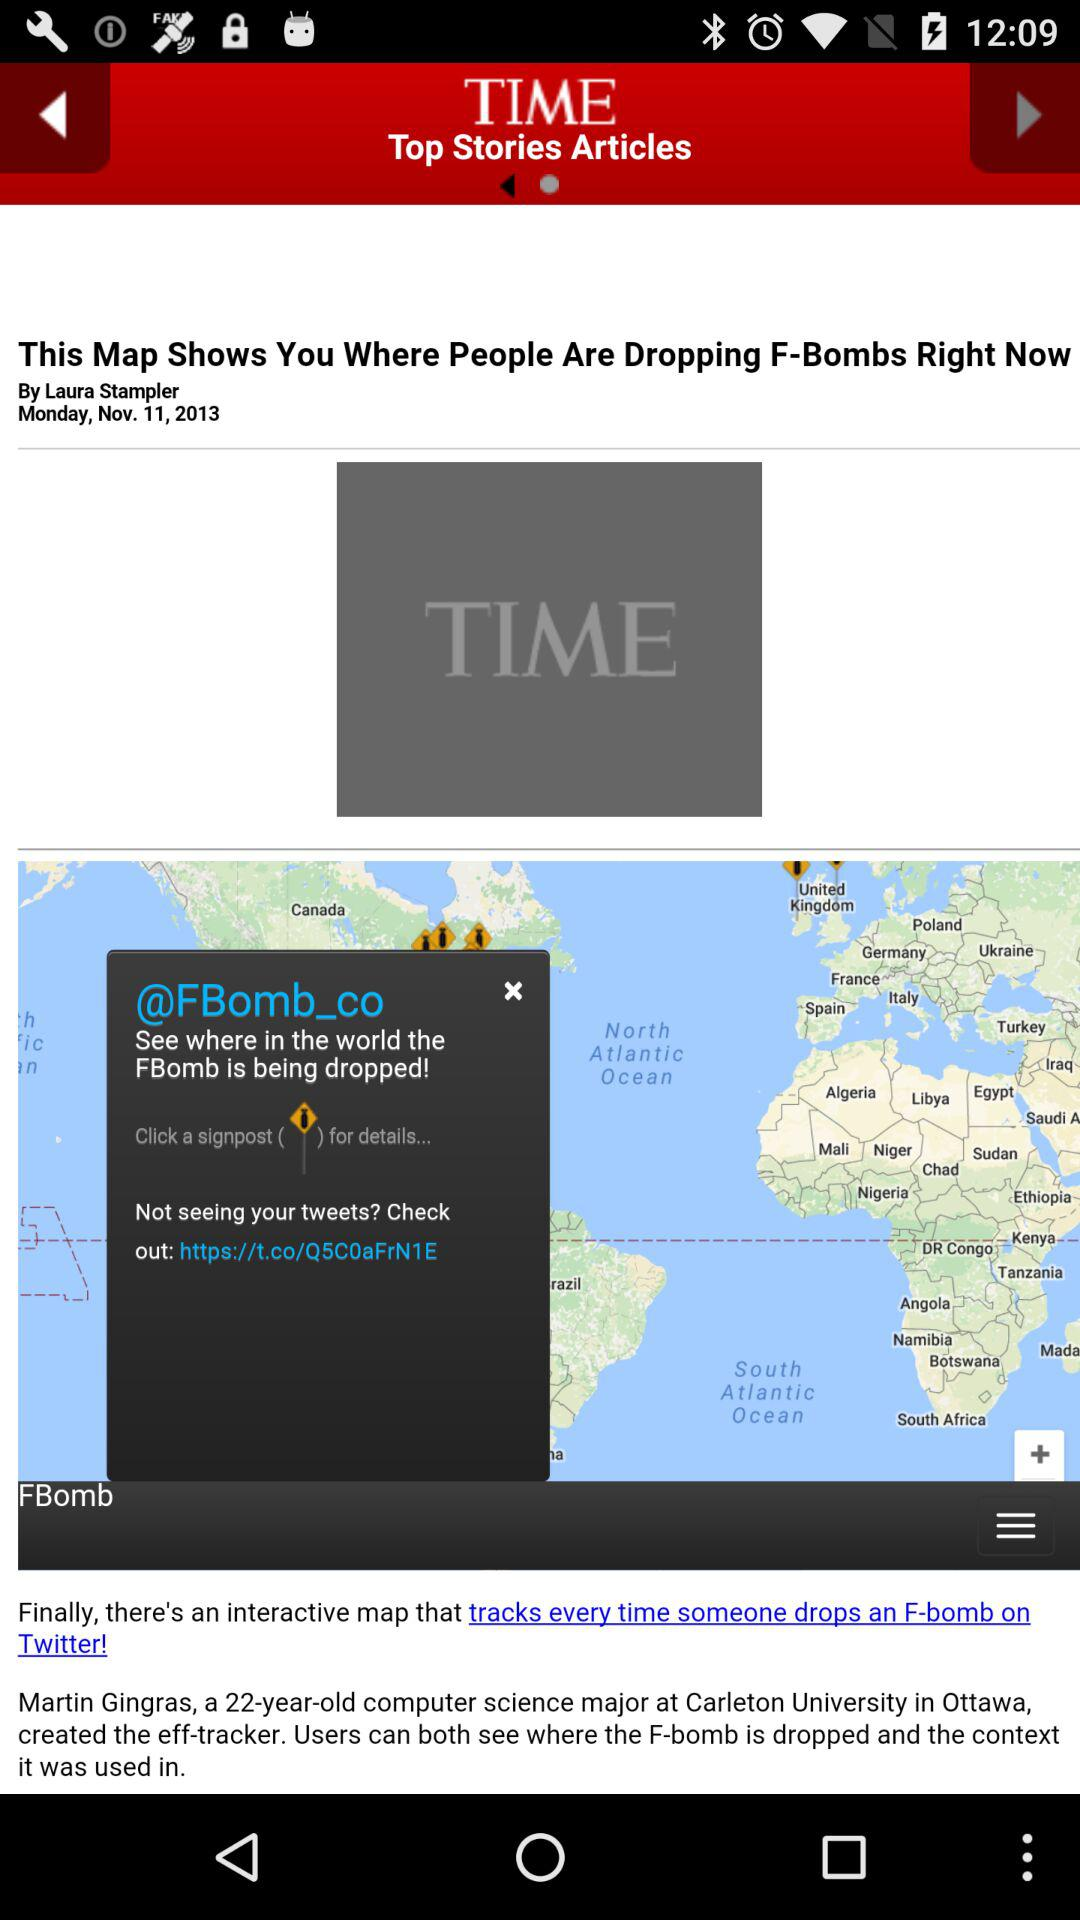What is the day on November 11th? The day is "Monday". 